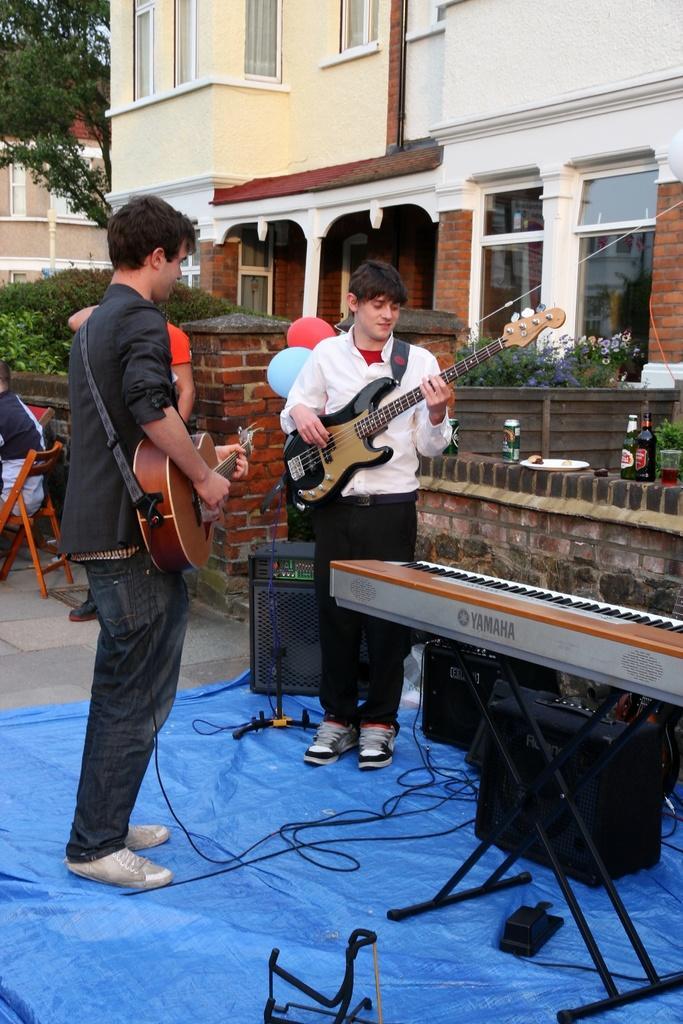Can you describe this image briefly? This man is standing and playing guitar. In-front of this man other person is also playing guitar. This is building with window. Beside this building there is a tree. We can able to see plants, bottles, tin, plated, speaker, cables, piano keyboard and person is sitting on a chair. 